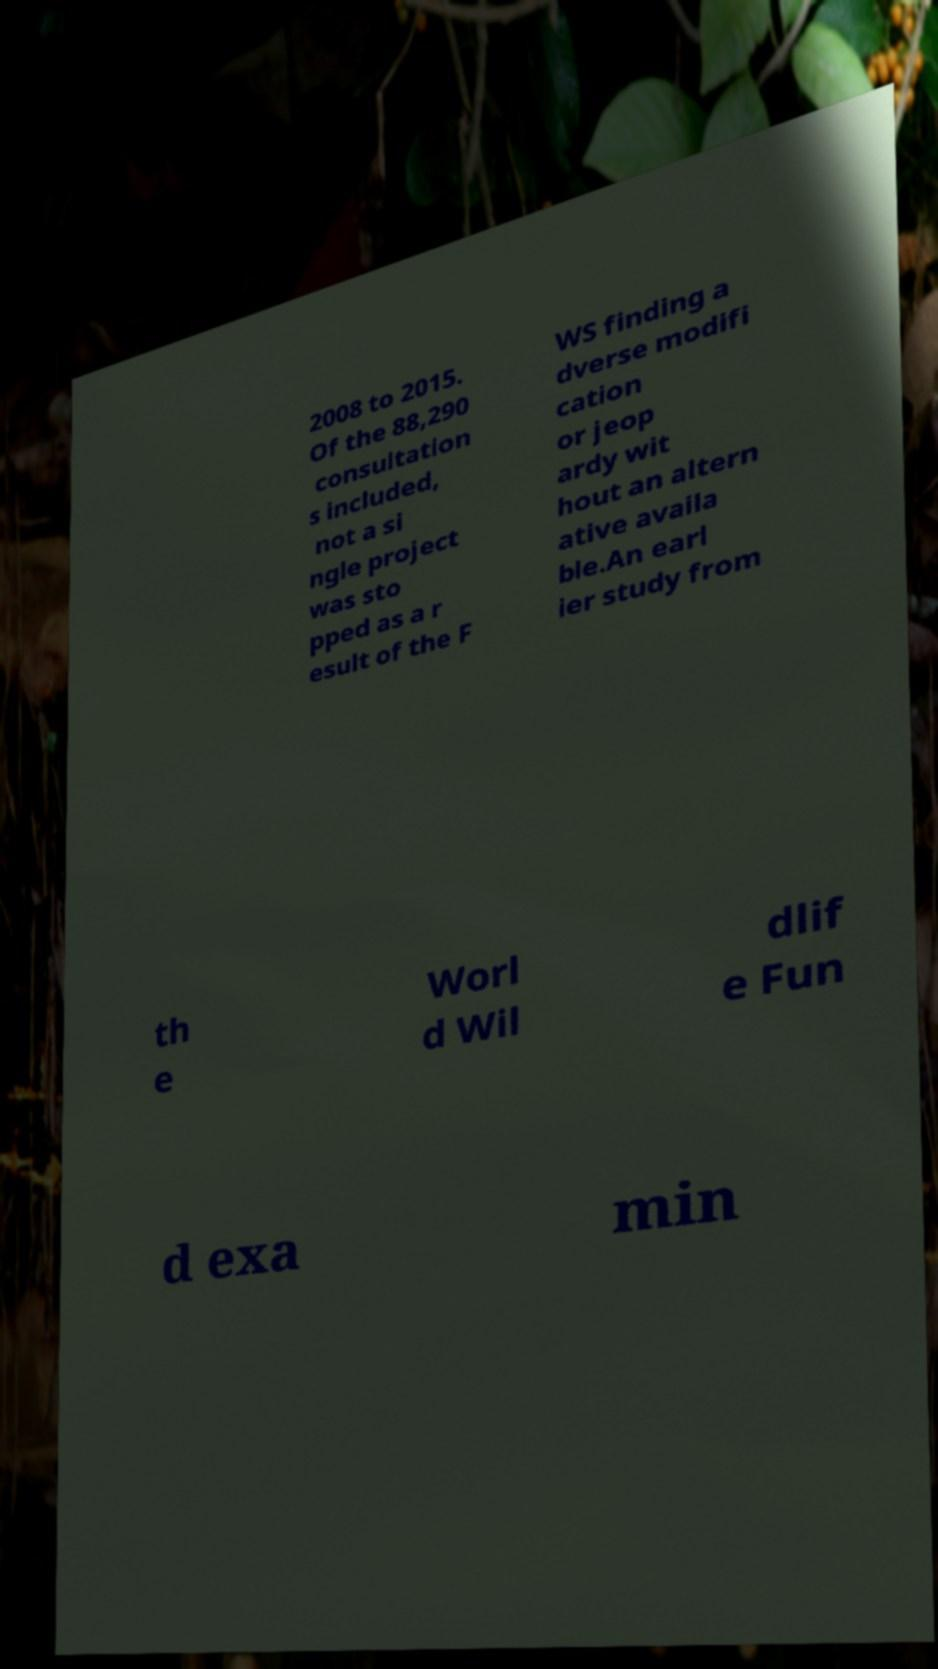I need the written content from this picture converted into text. Can you do that? 2008 to 2015. Of the 88,290 consultation s included, not a si ngle project was sto pped as a r esult of the F WS finding a dverse modifi cation or jeop ardy wit hout an altern ative availa ble.An earl ier study from th e Worl d Wil dlif e Fun d exa min 